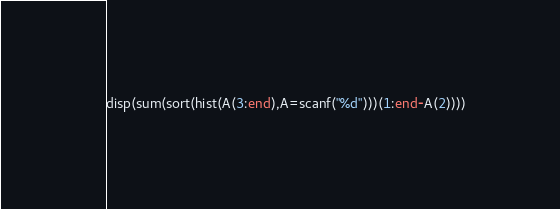Convert code to text. <code><loc_0><loc_0><loc_500><loc_500><_Octave_>disp(sum(sort(hist(A(3:end),A=scanf("%d")))(1:end-A(2))))</code> 